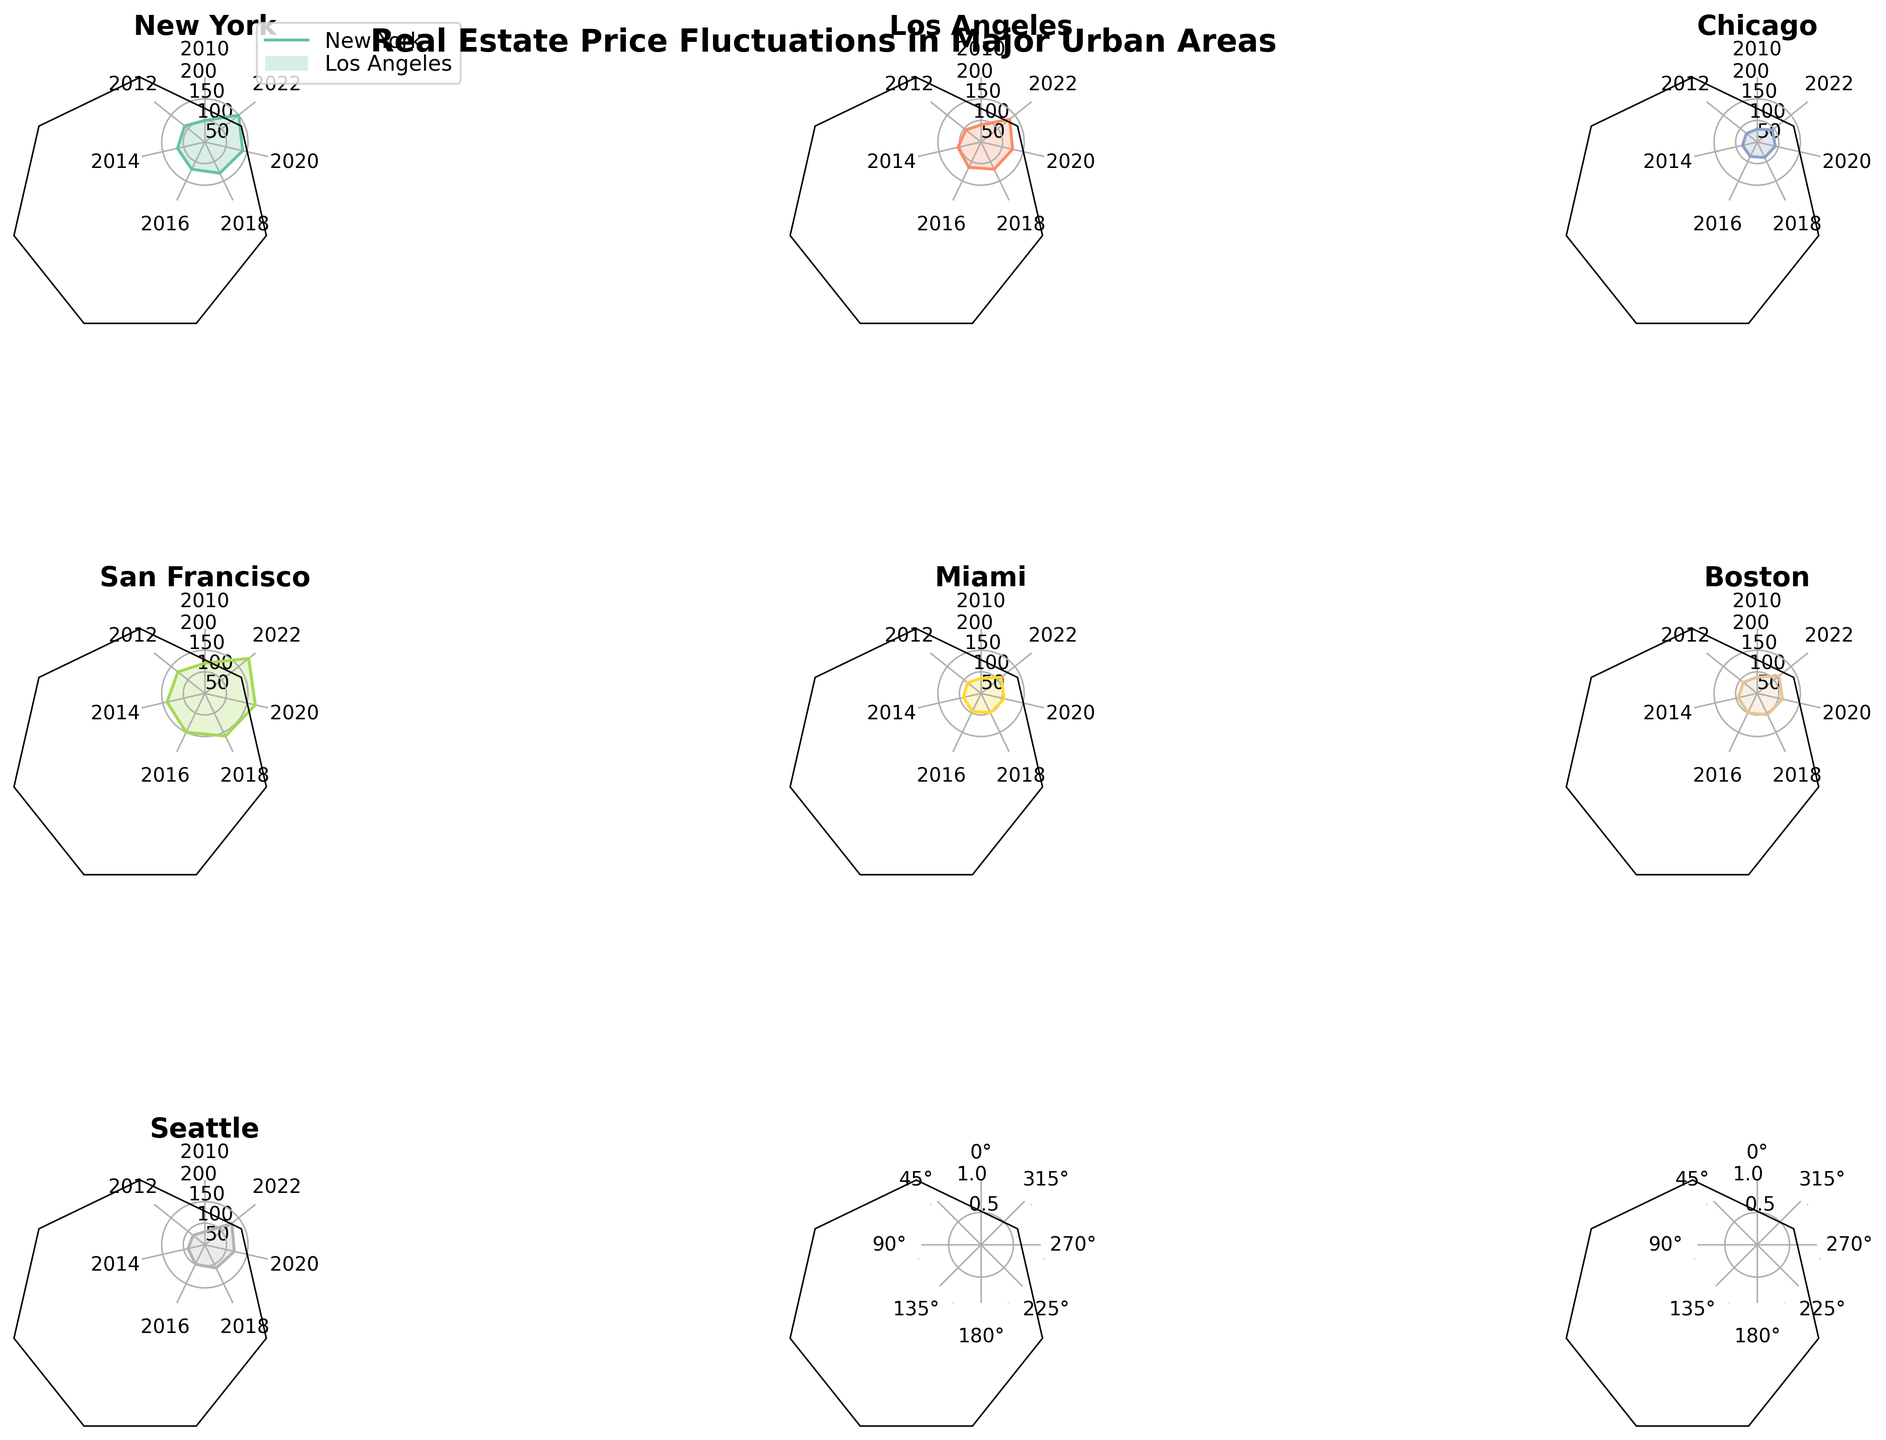How many years of data are represented for each city? Each subplot represents real estate price data from the years 2010, 2012, 2014, 2016, 2018, 2020, and 2022, which totals to 7 years.
Answer: 7 Which city shows the highest value at any given year? San Francisco reaches the highest value of 180 in the year 2022, according to its subplot.
Answer: San Francisco Compare the real estate price trends of New York and Miami. Which city had a more significant price increase from 2010 to 2022? New York increased from 100 to 150, giving a difference of 50. Miami increased from 85 to 110, giving a difference of 25. Therefore, New York had a more significant price increase.
Answer: New York For Chicago, what is the price difference between 2020 and 2022? Chicago's prices in 2020 and 2022 are 93 and 95, respectively. The difference is 95 - 93 = 2.
Answer: 2 Which cities have consistently higher real estate prices than Chicago in all represented years? Both New York and San Francisco exhibit consistently higher prices than Chicago in all noted years.
Answer: New York, San Francisco What is the average real estate price in Boston over all the years? Adding the prices in Boston for all the years (88, 91, 95, 100, 105, 110, 115) gives a total of 704. Dividing by the 7 years, 704 / 7 = 100.57.
Answer: 100.57 Which city shows the smallest fluctuation in real estate prices? Chicago has the smallest fluctuation, with values ranging from 80 to 95, a fluctuation of 15 points.
Answer: Chicago Identify the city with the most noticeable peak and valley in prices throughout the years. San Francisco shows a steady increase without significant peaks and valleys, making it less obvious for peaks and valleys compared to others like Miami or Seattle.
Answer: Miami Between Los Angeles and Seattle, which city had a price increase earlier and more steadily? Los Angeles shows a steady increase starting from 90 in 2010 to 135 in 2022 whereas Seattle's more rapid increases appear later, from 80 in 2010 up to 130 in 2022. Thus, Los Angeles had a steadier and earlier increase.
Answer: Los Angeles 